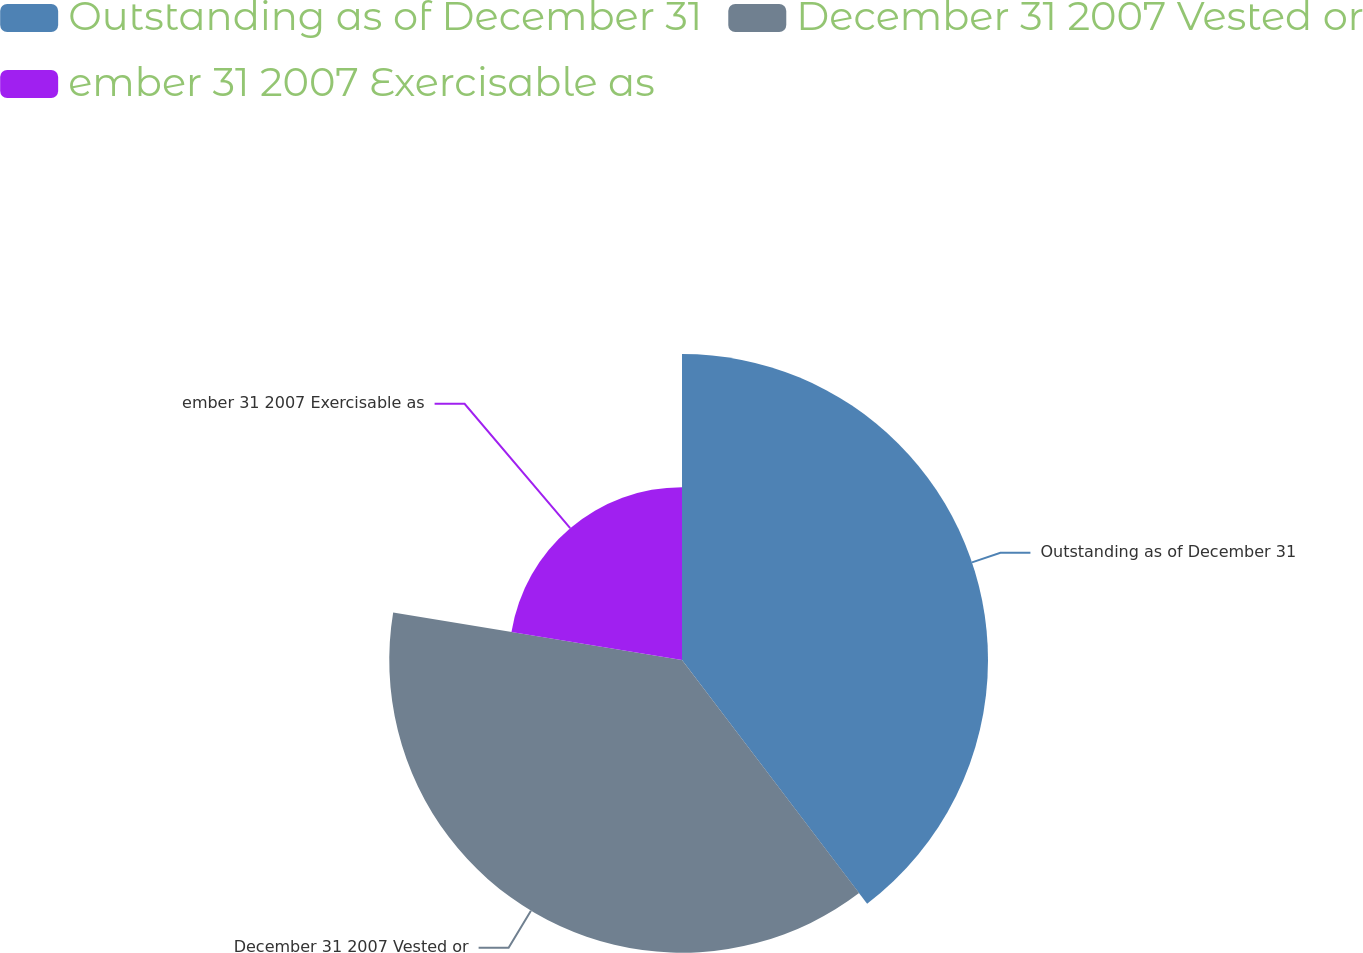Convert chart. <chart><loc_0><loc_0><loc_500><loc_500><pie_chart><fcel>Outstanding as of December 31<fcel>December 31 2007 Vested or<fcel>ember 31 2007 Exercisable as<nl><fcel>39.66%<fcel>37.94%<fcel>22.4%<nl></chart> 